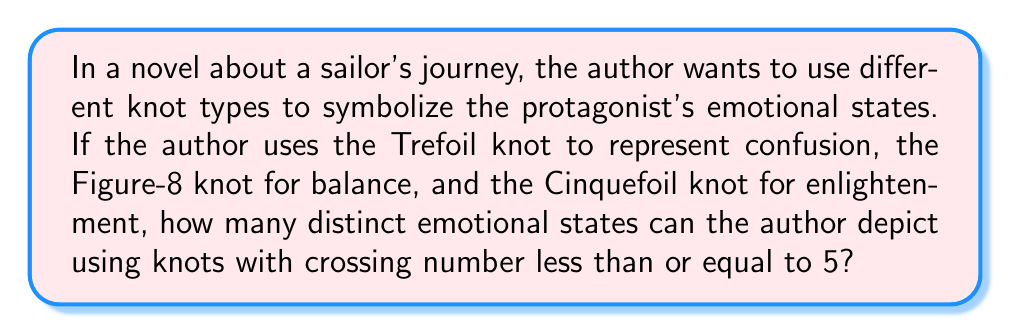Could you help me with this problem? To solve this problem, we need to understand the concept of crossing number in knot theory and count the number of prime knots with crossing number less than or equal to 5. Here's a step-by-step approach:

1. Crossing number: The crossing number of a knot is the minimum number of crossings in any diagram of the knot.

2. Prime knots: We consider prime knots, which are knots that cannot be decomposed into simpler knots.

3. Let's count the prime knots for each crossing number:
   - Crossing number 0: The unknot (1 knot)
   - Crossing number 3: The trefoil knot (1 knot)
   - Crossing number 4: The figure-eight knot (1 knot)
   - Crossing number 5: The cinquefoil knot and the three-twist knot (2 knots)

4. Sum up the total number of prime knots:
   $1 + 1 + 1 + 2 = 5$

Therefore, the author can use 5 distinct knot types to symbolize different emotional states in the story.

This approach allows the author to create a rich symbolism using mathematical concepts, enhancing the narrative by associating each knot type with a specific emotional state or plot development.
Answer: 5 distinct emotional states 